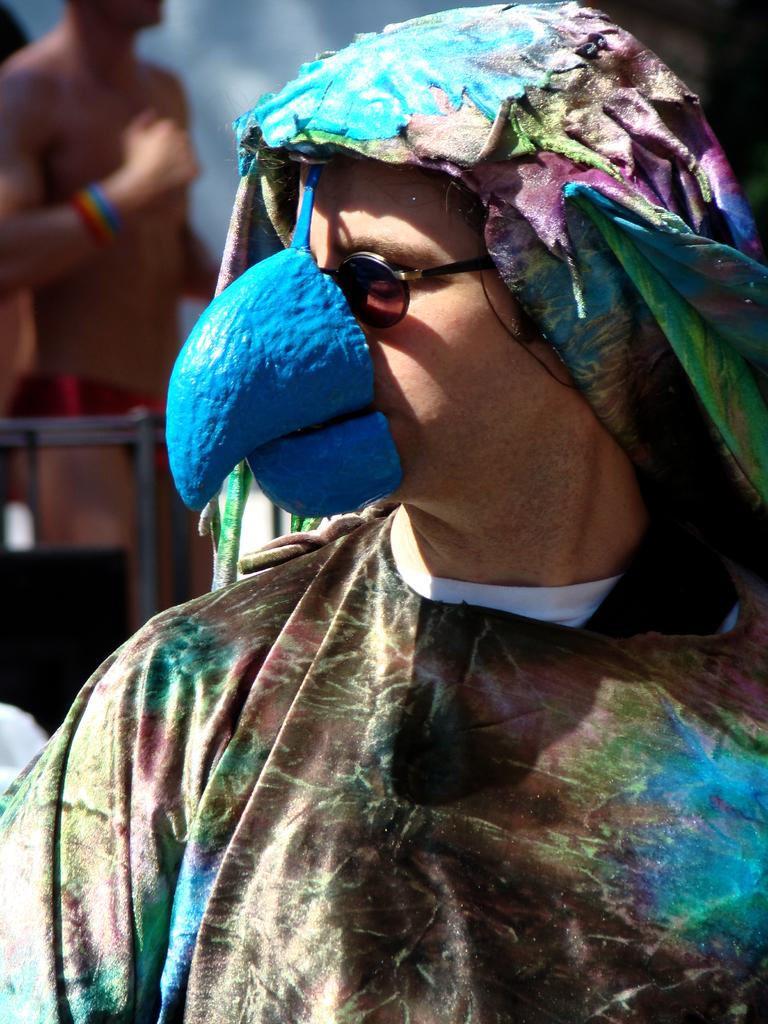What can be seen in the image? There is a person in the image. What is the person wearing? The person is wearing a costume. Can you describe the costume? The costume has different colors. What can be observed about the background of the image? The background of the image is blurred. How many babies are playing with the toy in the image? There is no toy or babies present in the image. What thoughts are going through the person's mind in the image? The image does not provide any information about the person's thoughts or mental state. 